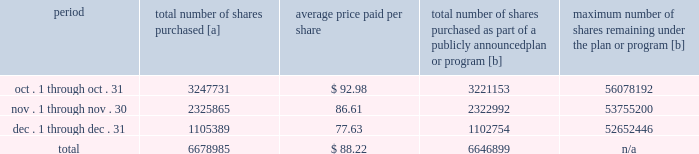Five-year performance comparison 2013 the following graph provides an indicator of cumulative total shareholder returns for the corporation as compared to the peer group index ( described above ) , the dj trans , and the s&p 500 .
The graph assumes that $ 100 was invested in the common stock of union pacific corporation and each index on december 31 , 2010 and that all dividends were reinvested .
The information below is historical in nature and is not necessarily indicative of future performance .
Purchases of equity securities 2013 during 2015 , we repurchased 36921641 shares of our common stock at an average price of $ 99.16 .
The table presents common stock repurchases during each month for the fourth quarter of 2015 : period total number of shares purchased [a] average price paid per share total number of shares purchased as part of a publicly announced plan or program [b] maximum number of shares remaining under the plan or program [b] .
[a] total number of shares purchased during the quarter includes approximately 32086 shares delivered or attested to upc by employees to pay stock option exercise prices , satisfy excess tax withholding obligations for stock option exercises or vesting of retention units , and pay withholding obligations for vesting of retention shares .
[b] effective january 1 , 2014 , our board of directors authorized the repurchase of up to 120 million shares of our common stock by december 31 , 2017 .
These repurchases may be made on the open market or through other transactions .
Our management has sole discretion with respect to determining the timing and amount of these transactions. .
In the fourth quarter ended december 31 , 2015 what was the percent of the total number of shares purchased that was attributable to the employees to pay stock option exercise prices , satisfy excess tax withholding obligations? 
Computations: (32086 / 6678985)
Answer: 0.0048. 